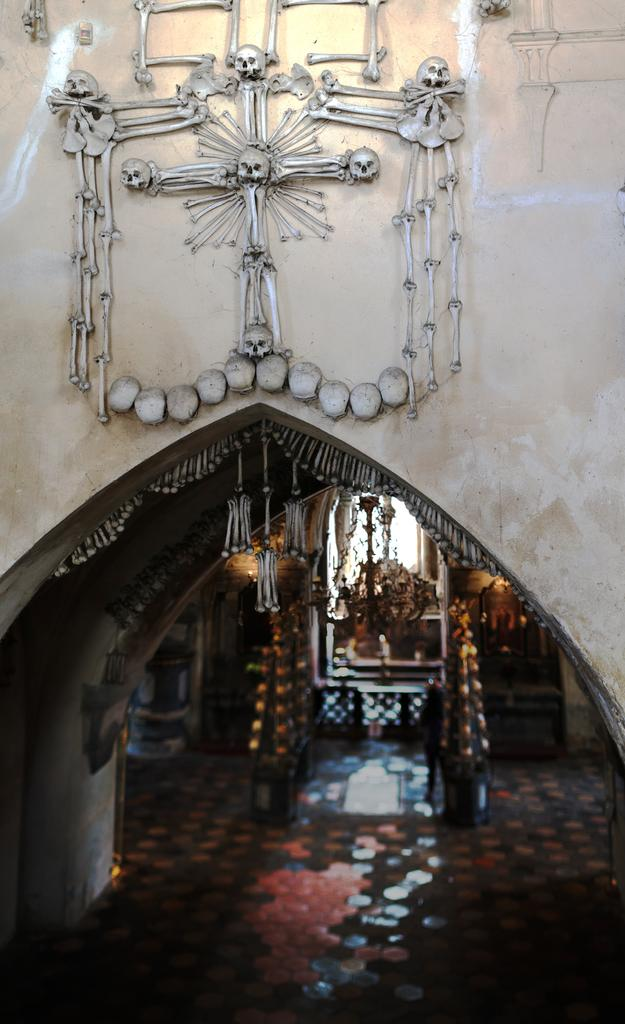What is depicted on the building wall in the image? There is a design with a skeleton on the building wall. Can you describe any specific features of the design? Yes, there is an arch in the design. Are there any objects within the design? Yes, there are objects inside the design. What grade did the skeleton receive for its learning in the image? There is no indication of learning or grades in the image; it simply features a design with a skeleton and an arch. 